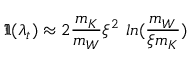Convert formula to latex. <formula><loc_0><loc_0><loc_500><loc_500>\Im ( \lambda _ { t } ) \approx 2 \frac { m _ { K } } { m _ { W } } \xi ^ { 2 } \ln ( \frac { m _ { W } } { \xi m _ { K } } )</formula> 